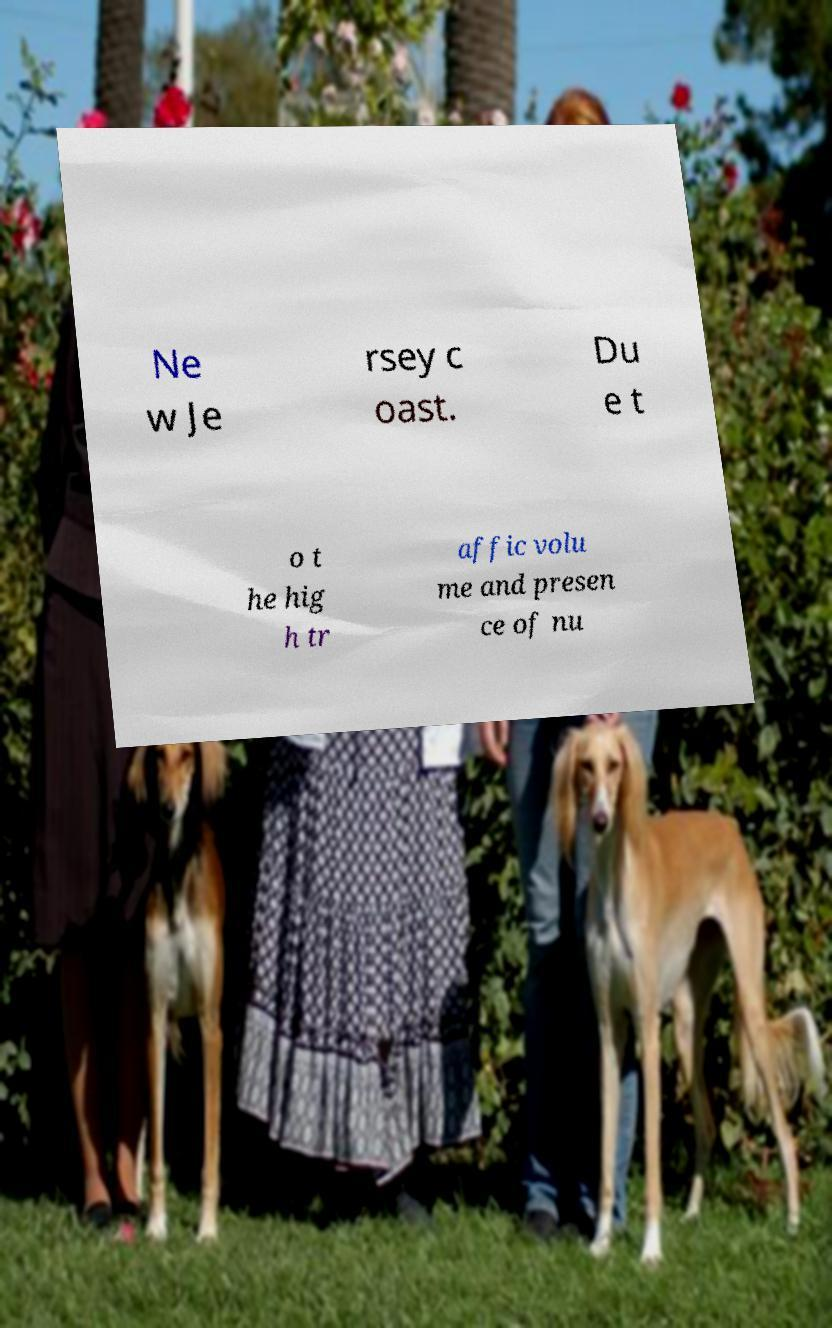I need the written content from this picture converted into text. Can you do that? Ne w Je rsey c oast. Du e t o t he hig h tr affic volu me and presen ce of nu 